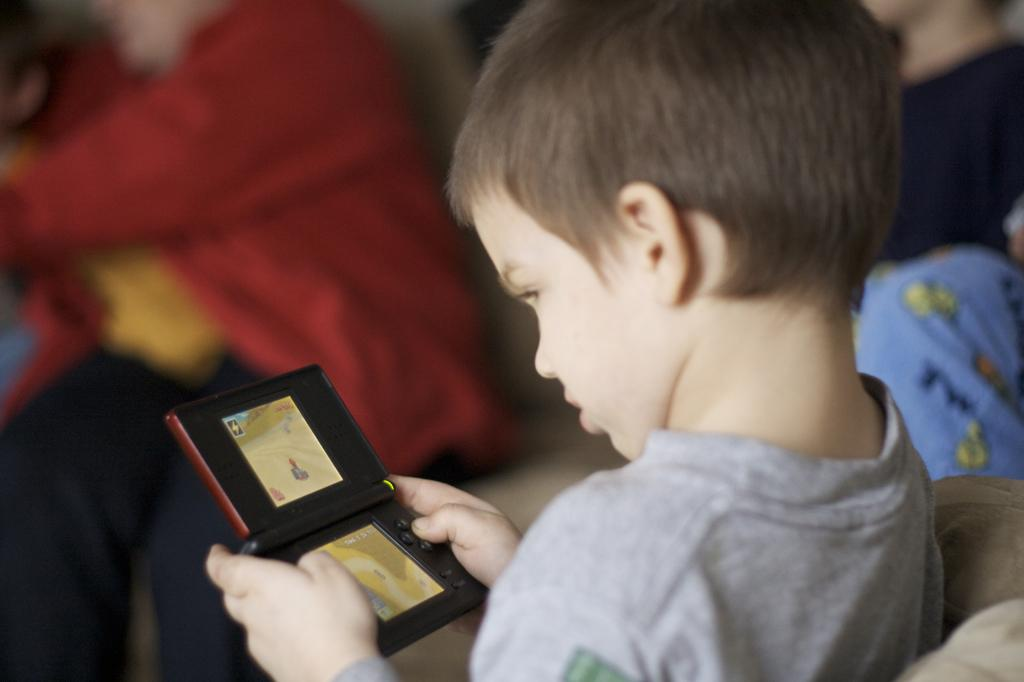What is the main subject of the image? The main subject of the image is a kid. What is the kid doing in the image? The kid is sitting on a chair in the image. What is the kid holding in his hand? The kid is holding an object in his hand. Can you describe the background of the image? The background of the image is blurred, and there are people visible in the background. What type of print can be seen on the kid's shirt in the image? There is no print visible on the kid's shirt in the image. Can you hear the kid whistling in the image? There is no sound in the image, so it is not possible to determine if the kid is whistling. 